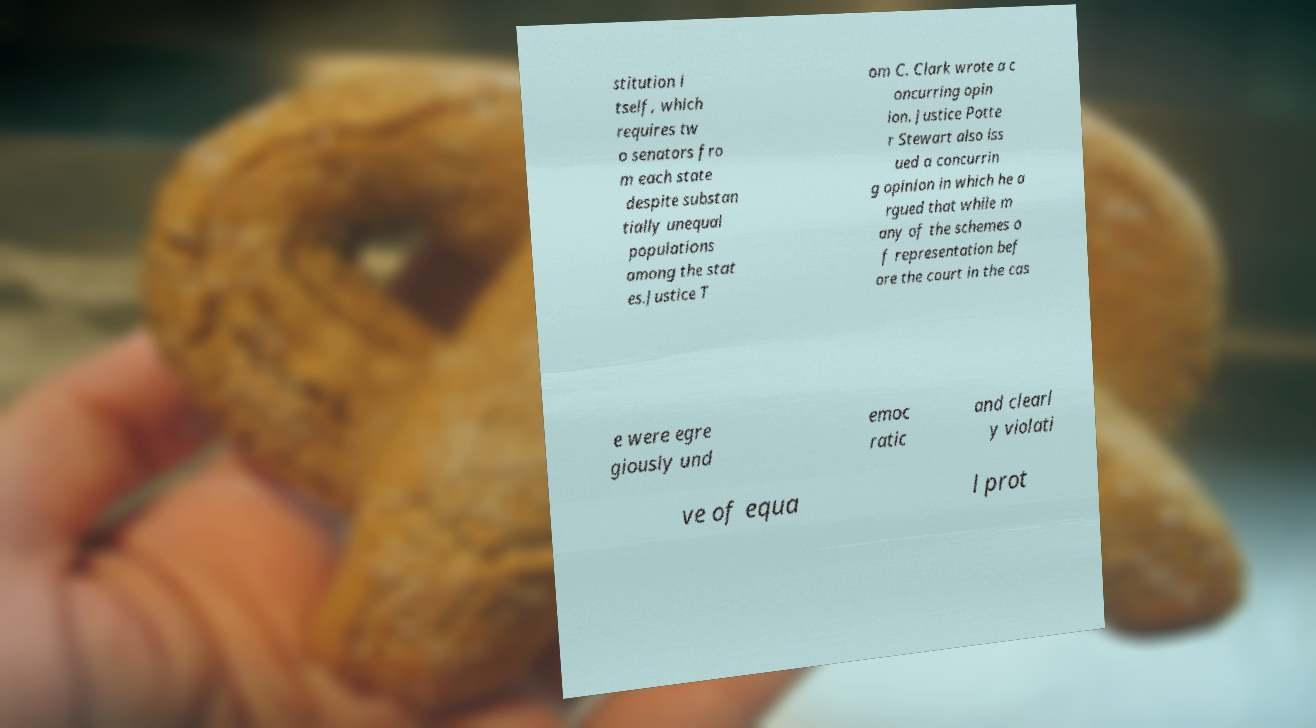What messages or text are displayed in this image? I need them in a readable, typed format. stitution i tself, which requires tw o senators fro m each state despite substan tially unequal populations among the stat es.Justice T om C. Clark wrote a c oncurring opin ion. Justice Potte r Stewart also iss ued a concurrin g opinion in which he a rgued that while m any of the schemes o f representation bef ore the court in the cas e were egre giously und emoc ratic and clearl y violati ve of equa l prot 